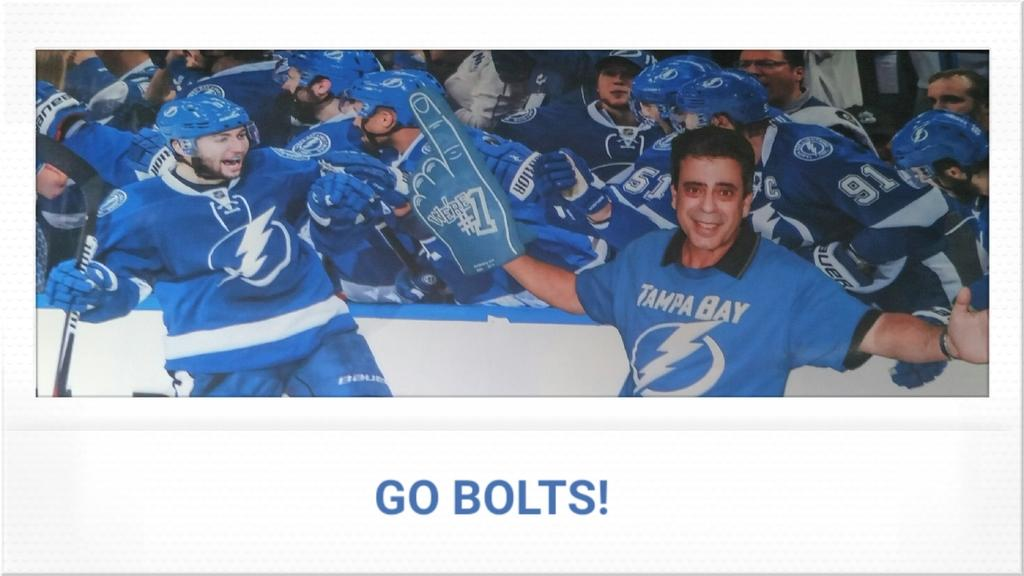Provide a one-sentence caption for the provided image. A man with a #1 thumb wearing a baby blue Tampa Bay hockey jersey poses with the team. 